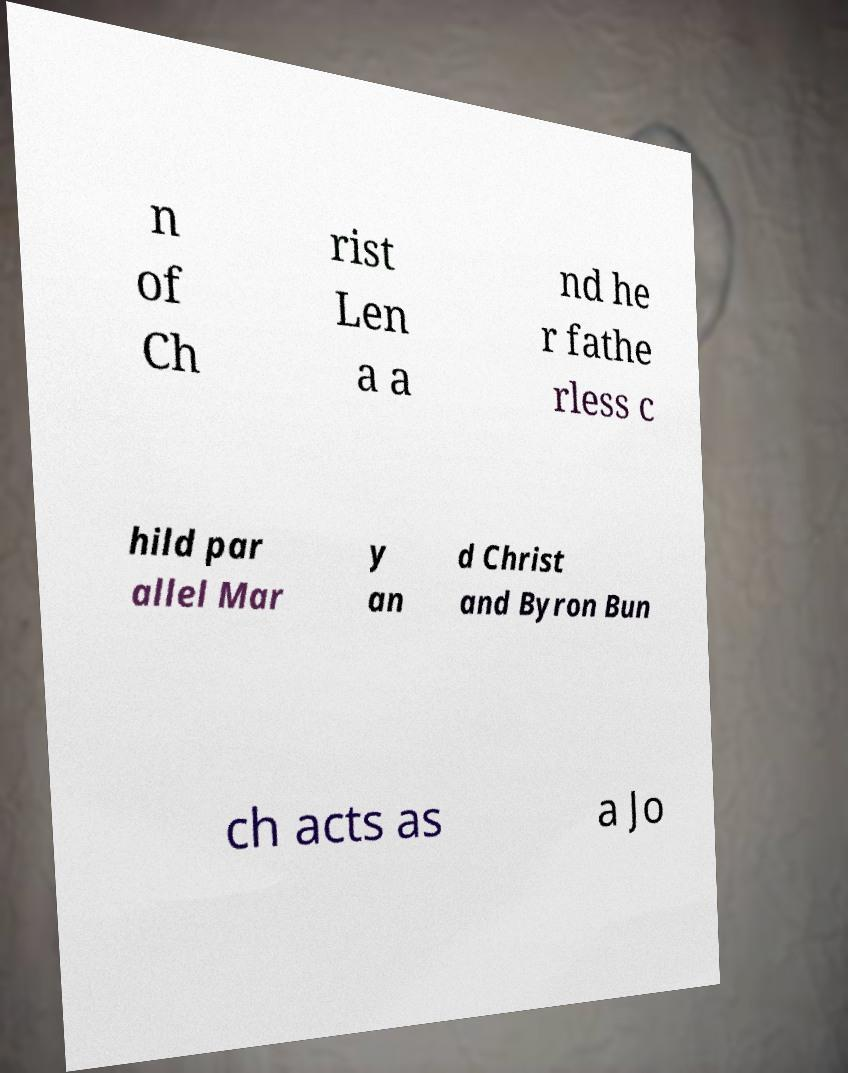Please read and relay the text visible in this image. What does it say? n of Ch rist Len a a nd he r fathe rless c hild par allel Mar y an d Christ and Byron Bun ch acts as a Jo 